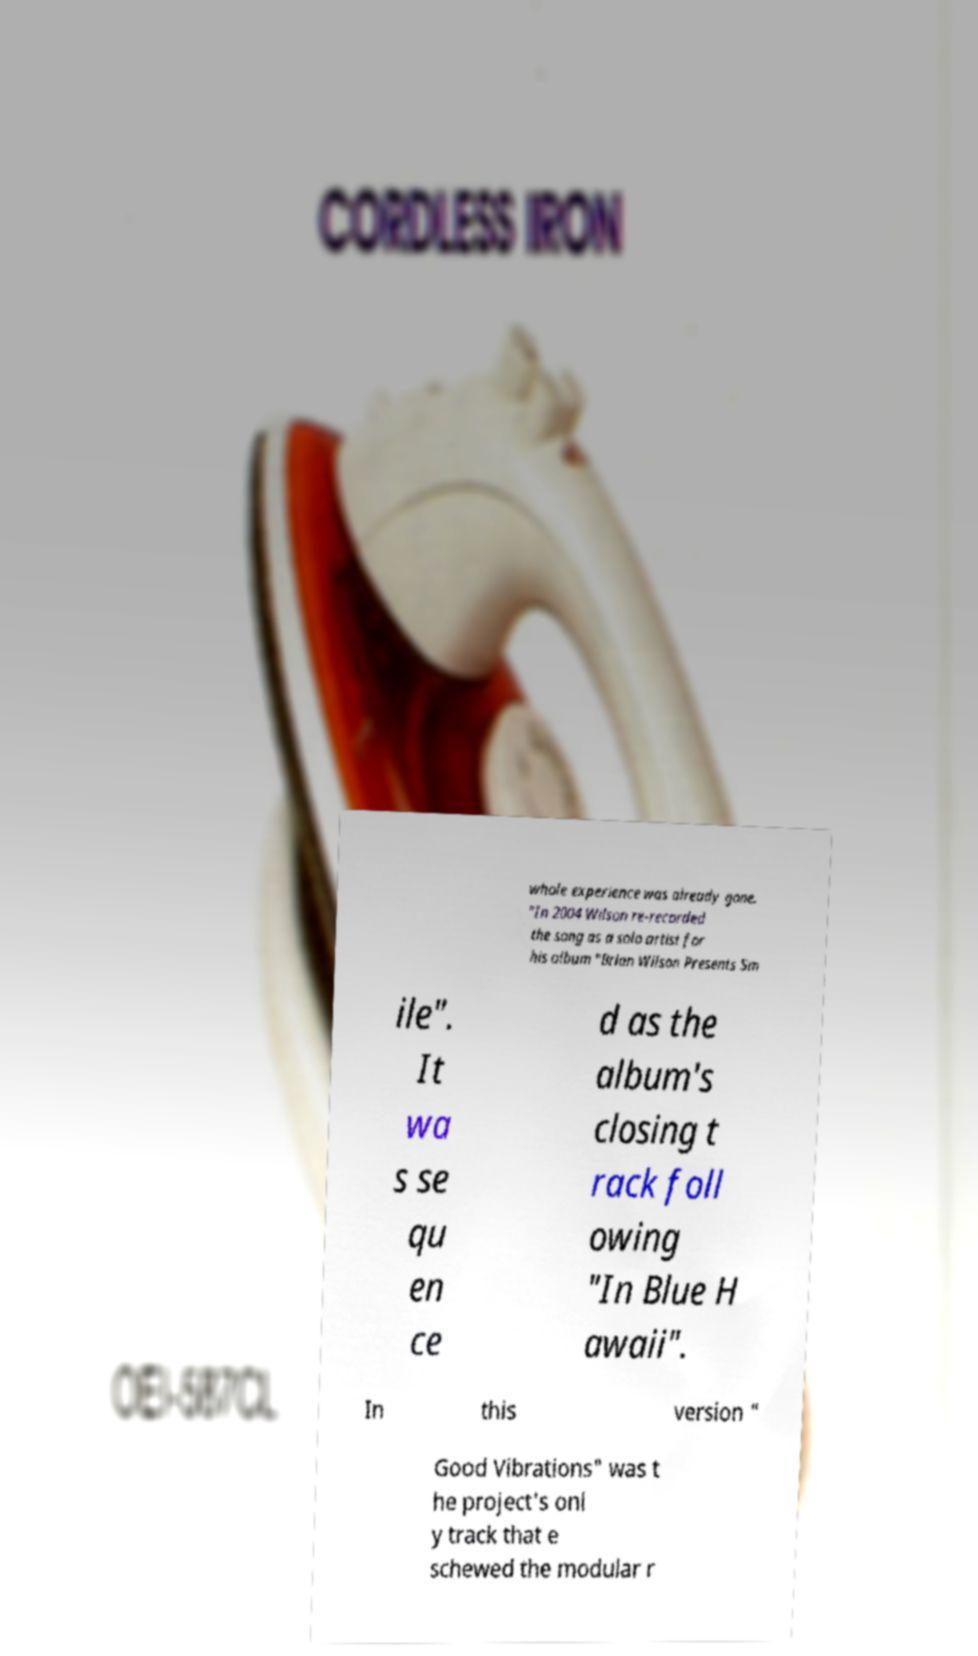Could you assist in decoding the text presented in this image and type it out clearly? whole experience was already gone. "In 2004 Wilson re-recorded the song as a solo artist for his album "Brian Wilson Presents Sm ile". It wa s se qu en ce d as the album's closing t rack foll owing "In Blue H awaii". In this version " Good Vibrations" was t he project's onl y track that e schewed the modular r 